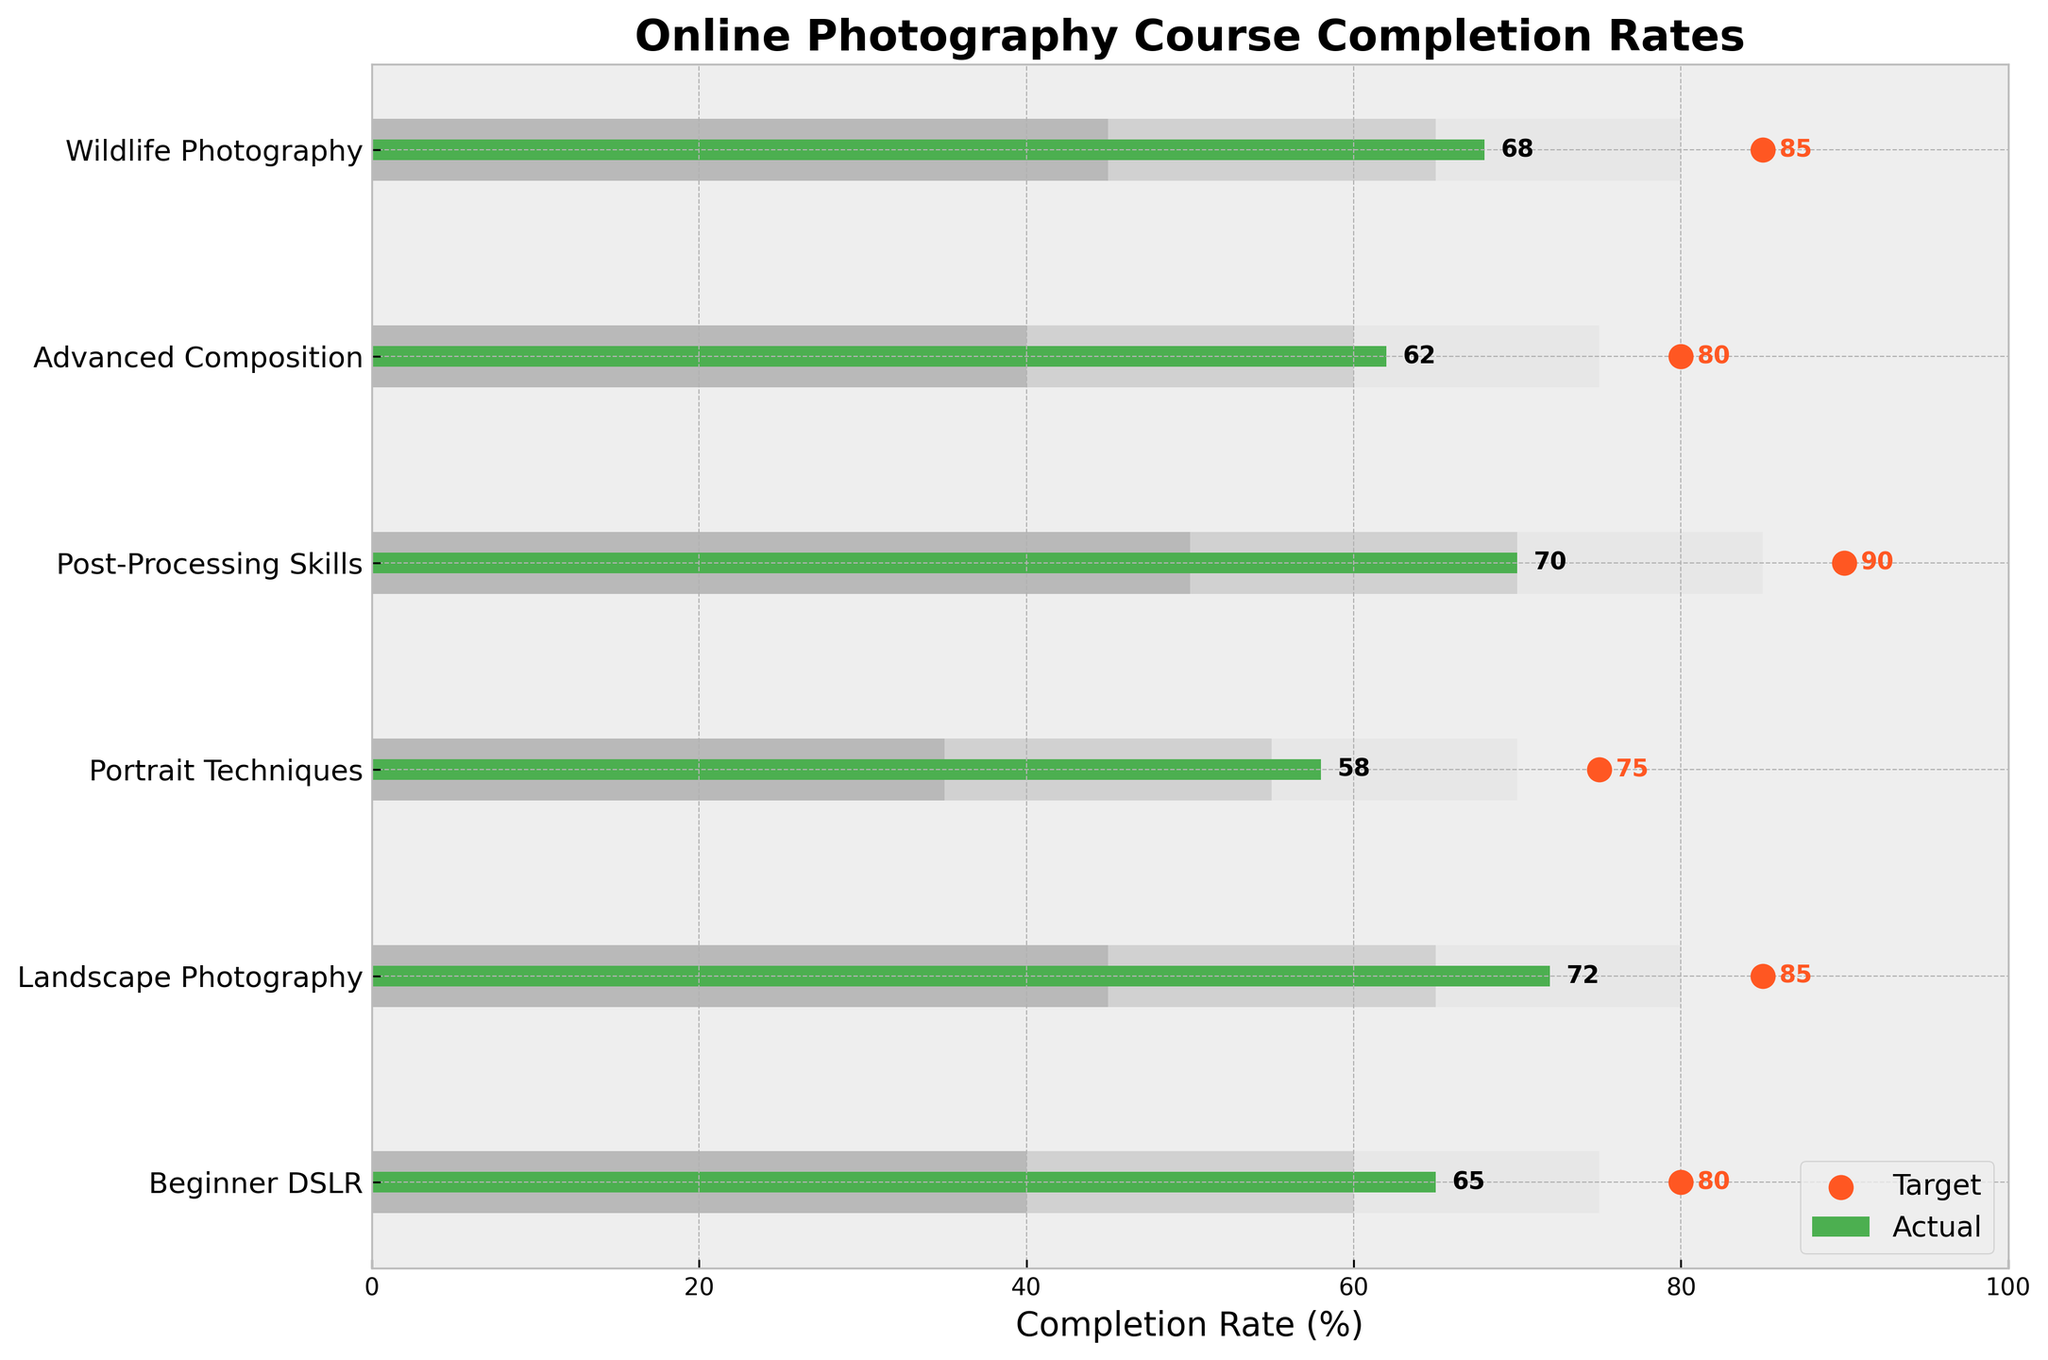What is the title of the figure? The title of the figure is typically displayed at the top. In this figure, it reads "Online Photography Course Completion Rates."
Answer: Online Photography Course Completion Rates What category has the highest actual completion rate? To determine the highest actual completion rate, we compare the bar lengths representing actual completion rates for each category. The "Landscape Photography" category has the longest bar with an actual completion rate of 72%.
Answer: Landscape Photography What is the completion rate target for the "Advanced Composition" category? The target values are depicted by the scatter points along the x-axis. For "Advanced Composition," the scatter point aligns with the value of 80.
Answer: 80 How many categories have an actual completion rate above 65%? By examining the length of the bars representing actual completion rates and comparing each to 65%, we see that "Beginner DSLR" (65%), "Landscape Photography" (72%), "Post-Processing Skills" (70%), and "Wildlife Photography" (68%) are above 65%. There are 4 categories.
Answer: 4 For which categories do the actual completion rates fall within the third range? The third range for each category is depicted by the darkest bar segments. The actual completion rates falling within these ranges are compared. "Beginner DSLR" (40-75), "Portrait Techniques" (35-70), "Advanced Composition" (40-75). Only "Portrait Techniques" has an actual completion rate of 58 falling within the range of 35-70.
Answer: Portrait Techniques How does the actual completion rate for "Wildlife Photography" compare to its target? "Wildlife Photography" has an actual completion rate of 68 and a target of 85. To find the difference: 85 (target) - 68 (actual) = 17. The actual completion rate is 17 percentage points below the target.
Answer: 17 percentage points below Which category has the smallest gap between actual completion rate and target? To find the smallest gap, we calculate the difference between actual and target rates for all categories: "Beginner DSLR" (80-65=15), "Landscape Photography" (85-72=13), "Portrait Techniques" (75-58=17), "Post-Processing Skills" (90-70=20), "Advanced Composition" (80-62=18), "Wildlife Photography" (85-68=17). "Landscape Photography" has the smallest gap of 13.
Answer: Landscape Photography What is the average target completion rate across all categories? Add up the target completion rates and divide by the total number of categories. (80 + 85 + 75 + 90 + 80 + 85) / 6 = 495 / 6 = 82.5
Answer: 82.5 